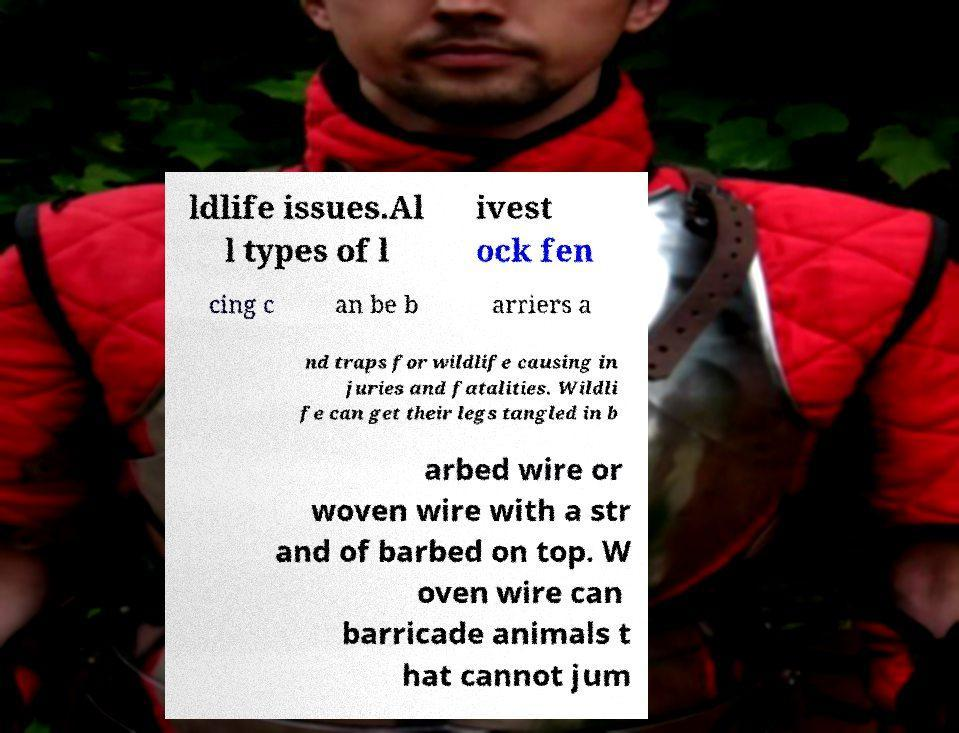Can you read and provide the text displayed in the image?This photo seems to have some interesting text. Can you extract and type it out for me? ldlife issues.Al l types of l ivest ock fen cing c an be b arriers a nd traps for wildlife causing in juries and fatalities. Wildli fe can get their legs tangled in b arbed wire or woven wire with a str and of barbed on top. W oven wire can barricade animals t hat cannot jum 